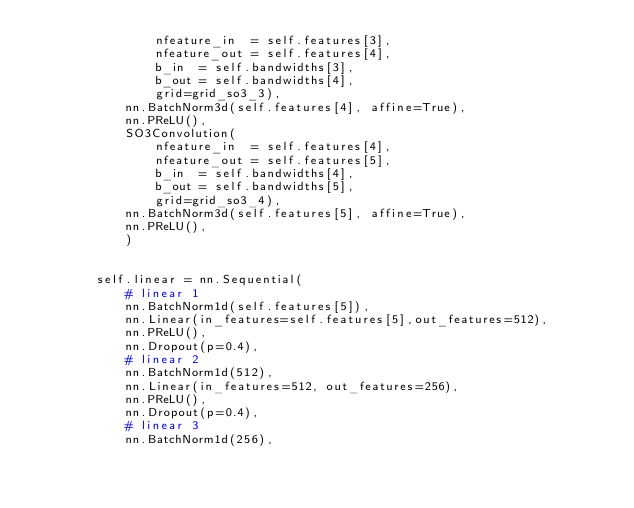Convert code to text. <code><loc_0><loc_0><loc_500><loc_500><_Python_>                nfeature_in  = self.features[3],
                nfeature_out = self.features[4],
                b_in  = self.bandwidths[3],
                b_out = self.bandwidths[4],
                grid=grid_so3_3),
            nn.BatchNorm3d(self.features[4], affine=True),
            nn.PReLU(),
            SO3Convolution(
                nfeature_in  = self.features[4],
                nfeature_out = self.features[5],
                b_in  = self.bandwidths[4],
                b_out = self.bandwidths[5],
                grid=grid_so3_4),
            nn.BatchNorm3d(self.features[5], affine=True),
            nn.PReLU(),
            )


        self.linear = nn.Sequential(
            # linear 1
            nn.BatchNorm1d(self.features[5]),
            nn.Linear(in_features=self.features[5],out_features=512),
            nn.PReLU(),
            nn.Dropout(p=0.4),
            # linear 2
            nn.BatchNorm1d(512),
            nn.Linear(in_features=512, out_features=256),
            nn.PReLU(),
            nn.Dropout(p=0.4),
            # linear 3
            nn.BatchNorm1d(256),</code> 